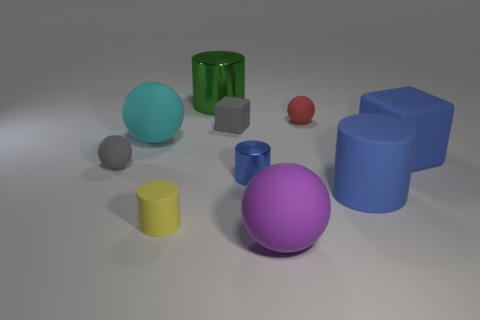Can you describe the texture and finish of the objects, and what does this tell us about the materials they're made of? Certainly! The objects in the image exhibit various textures and finishes. For instance, the green cylinder appears to have a glossy, reflective surface, suggesting a material like glass or polished plastic. In contrast, the large purple and blue spheres have a matte finish, which might indicate a softer, less reflective material like rubber. The gray cubes and the yellow cylinder have a light-absorbing surface, perhaps indicative of a stone or matte painted wood, while the metallic cylinder presents a shiny, reflective chrome-like finish. 